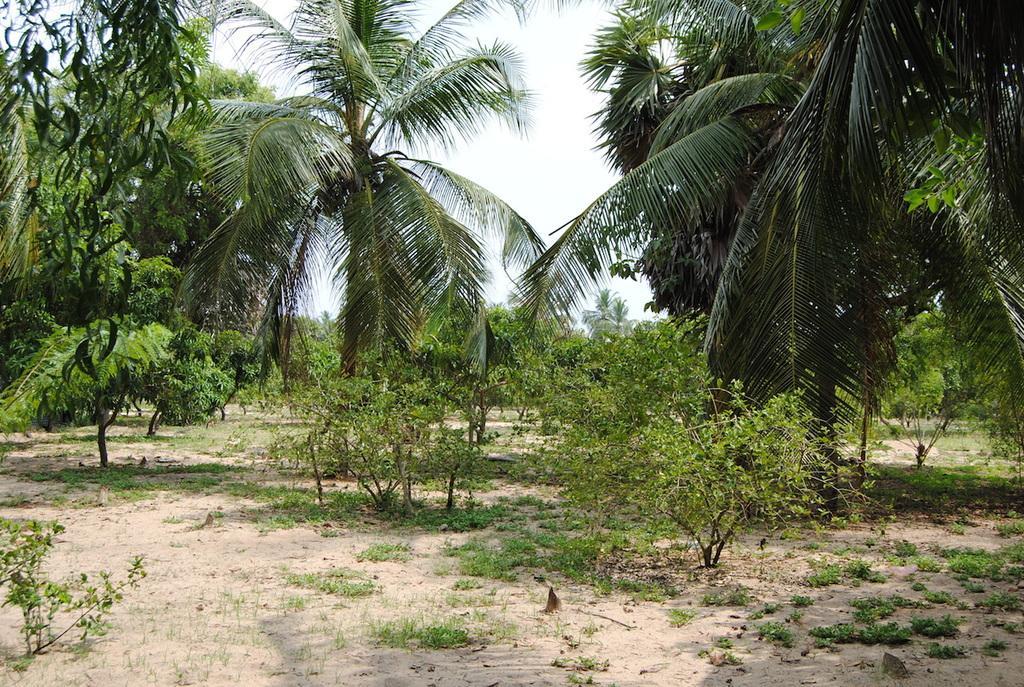Can you describe this image briefly? In this picture we can see trees in the background, we can see some plants and grass at the bottom, there is the sky at the top of the picture. 